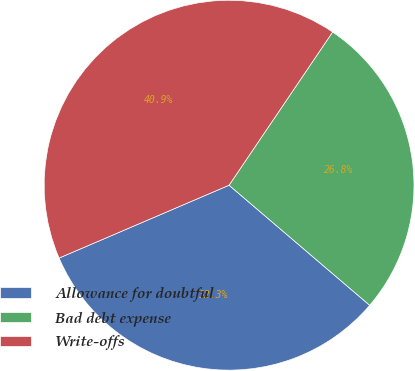Convert chart. <chart><loc_0><loc_0><loc_500><loc_500><pie_chart><fcel>Allowance for doubtful<fcel>Bad debt expense<fcel>Write-offs<nl><fcel>32.31%<fcel>26.79%<fcel>40.91%<nl></chart> 